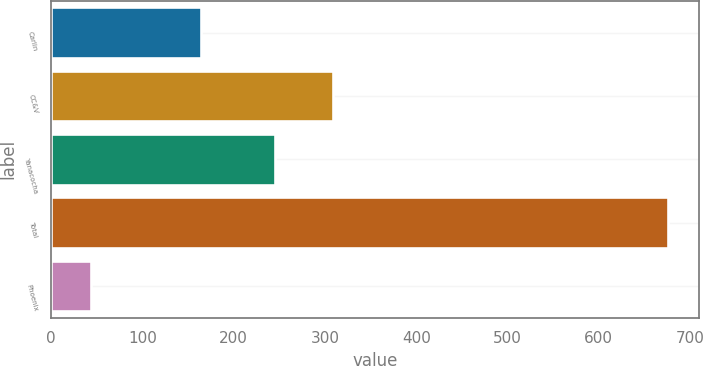Convert chart. <chart><loc_0><loc_0><loc_500><loc_500><bar_chart><fcel>Carlin<fcel>CC&V<fcel>Yanacocha<fcel>Total<fcel>Phoenix<nl><fcel>164<fcel>308.2<fcel>245<fcel>676<fcel>44<nl></chart> 